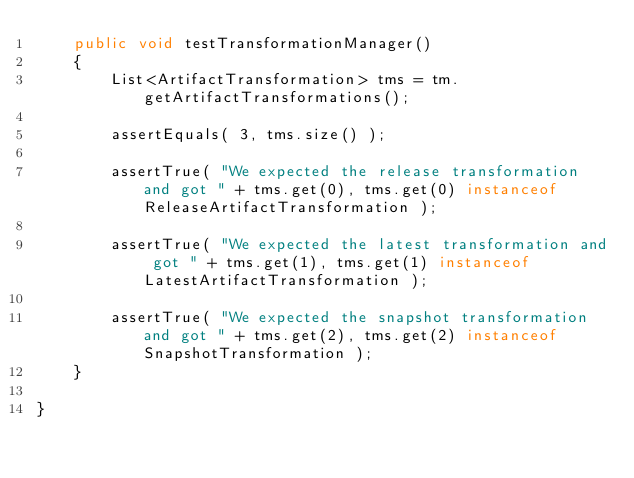<code> <loc_0><loc_0><loc_500><loc_500><_Java_>    public void testTransformationManager()
    {
        List<ArtifactTransformation> tms = tm.getArtifactTransformations();

        assertEquals( 3, tms.size() );

        assertTrue( "We expected the release transformation and got " + tms.get(0), tms.get(0) instanceof ReleaseArtifactTransformation );

        assertTrue( "We expected the latest transformation and got " + tms.get(1), tms.get(1) instanceof LatestArtifactTransformation );

        assertTrue( "We expected the snapshot transformation and got " + tms.get(2), tms.get(2) instanceof SnapshotTransformation );
    }

}
</code> 